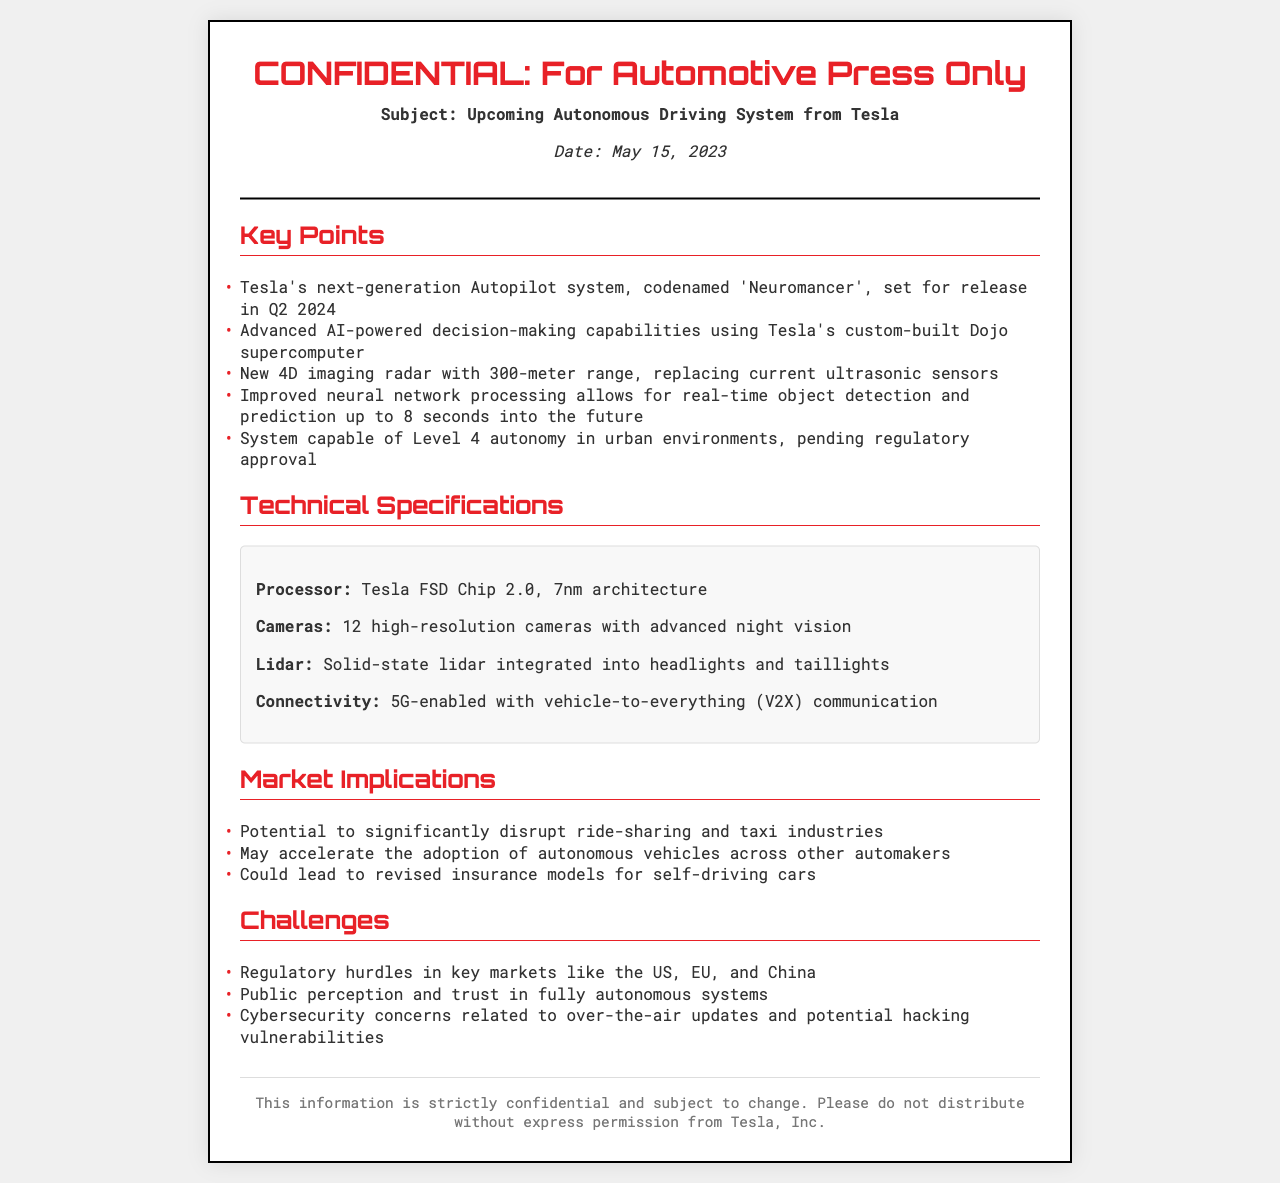What is the codename of Tesla's upcoming autonomous driving system? The codename is mentioned in the document as 'Neuromancer'.
Answer: Neuromancer When is the release date of the new Autopilot system? The document states that the release is set for Q2 2024.
Answer: Q2 2024 What type of radar is included in the system? The document describes the radar as a new 4D imaging radar with a 300-meter range.
Answer: 4D imaging radar How many high-resolution cameras are included in the system? The document specifies that there are 12 high-resolution cameras.
Answer: 12 What level of autonomy is the system aiming for? The document indicates the system is capable of Level 4 autonomy.
Answer: Level 4 What is a potential market implication mentioned regarding ride-sharing? The document suggests that the system has the potential to disrupt the ride-sharing and taxi industries.
Answer: Disrupt ride-sharing What is one of the challenges related to public perception? The document highlights public trust in fully autonomous systems as a challenge.
Answer: Trust What architecture is the Tesla FSD Chip 2.0 based on? The document states that the architecture is 7nm.
Answer: 7nm What is the document's confidentiality status? The document is strictly confidential and subject to change, emphasizing that it should not be distributed.
Answer: Confidential 